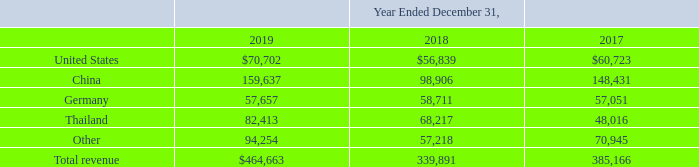Operating Segments
The Company operates as one operating segment. Operating segments are defined as components of an enterprise for which separate financial information is regularly evaluated by the chief operating decision maker (“CODM”), which is the Company’s chief executive officer, in deciding how to allocate resources and assess performance. The Company’s CODM evaluates the Company’s financial information for the purpose of allocating resources and assessing the performance of these resources on a consolidated basis. The Company operates as one operating segment. Operating segments are defined as components of an enterprise for which separate financial information is regularly evaluated by the chief operating decision maker (“CODM”), which is the Company’s chief executive officer, in deciding how to allocate resources and assess performance. The Company’s CODM evaluates the Company’s financial information for the purpose of allocating resources and assessing the performance of these resources on a consolidated basis.
Revenue by geographic country, based on ship-to destinations, which in certain instances may be the location of a contract manufacturer rather than the Company’s end customer, was as follows (in thousands):
What are operating segments? Operating segments are defined as components of an enterprise for which separate financial information is regularly evaluated by the chief operating decision maker (“codm”), which is the company’s chief executive officer, in deciding how to allocate resources and assess performance. Who evaluates the Company's financial information for the purpose of resource allocation and performance assessment? The company’s codm, chief operating decision maker (“codm”). What is revenue by geographic country based on? Ship-to destinations. What is the proportion of revenue by US in the total revenue in 2019?  70,702/464,663
Answer: 0.15. What is the percentage increase in revenue by China from 2018 to 2019?
Answer scale should be: percent. (159,637-98,906)/98,906
Answer: 61.4. What is the total revenue in Thailand between 2017 to 2019?
Answer scale should be: thousand. 82,413+68,217+48,016
Answer: 198646. 